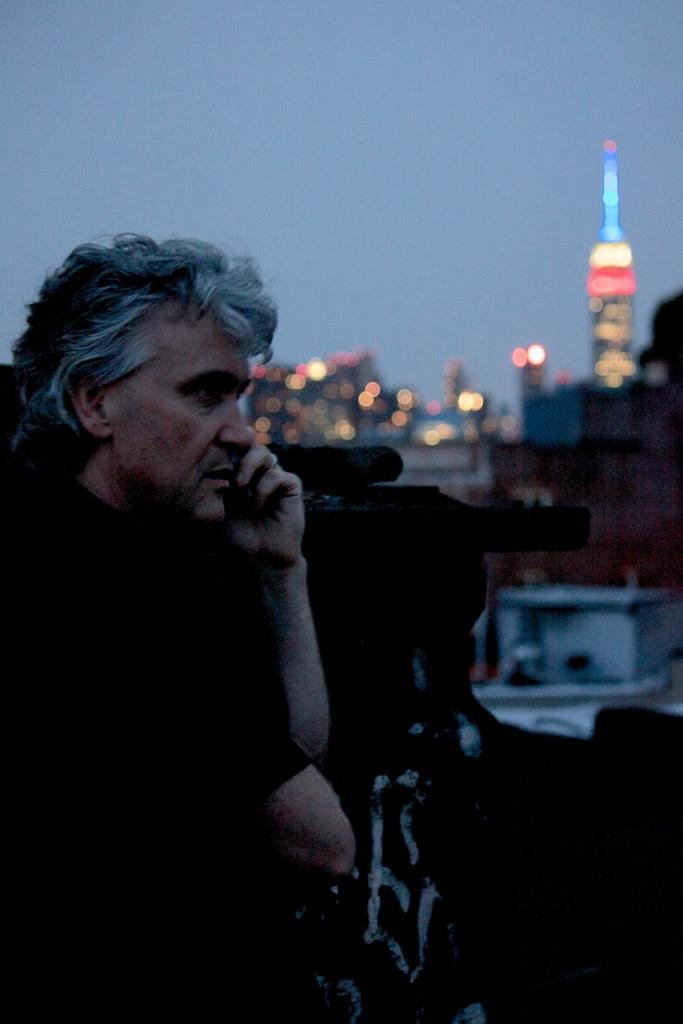What is the main subject of the image? There is a man standing in the image. What can be seen in the background of the image? There are buildings in the background of the image. What feature do the buildings have? The buildings have lights. What is visible at the top of the image? The sky is visible at the top of the image. Can you describe any object in the foreground of the image? There might be an object in the foreground of the image, but it is not specified in the facts. What type of apparel is the man wearing in the image? The facts provided do not mention the man's apparel, so we cannot determine what type of clothing he is wearing. Can you tell me how the man expresses love in the image? There is no indication of love or any related emotions in the image, so we cannot determine how the man might express love. 